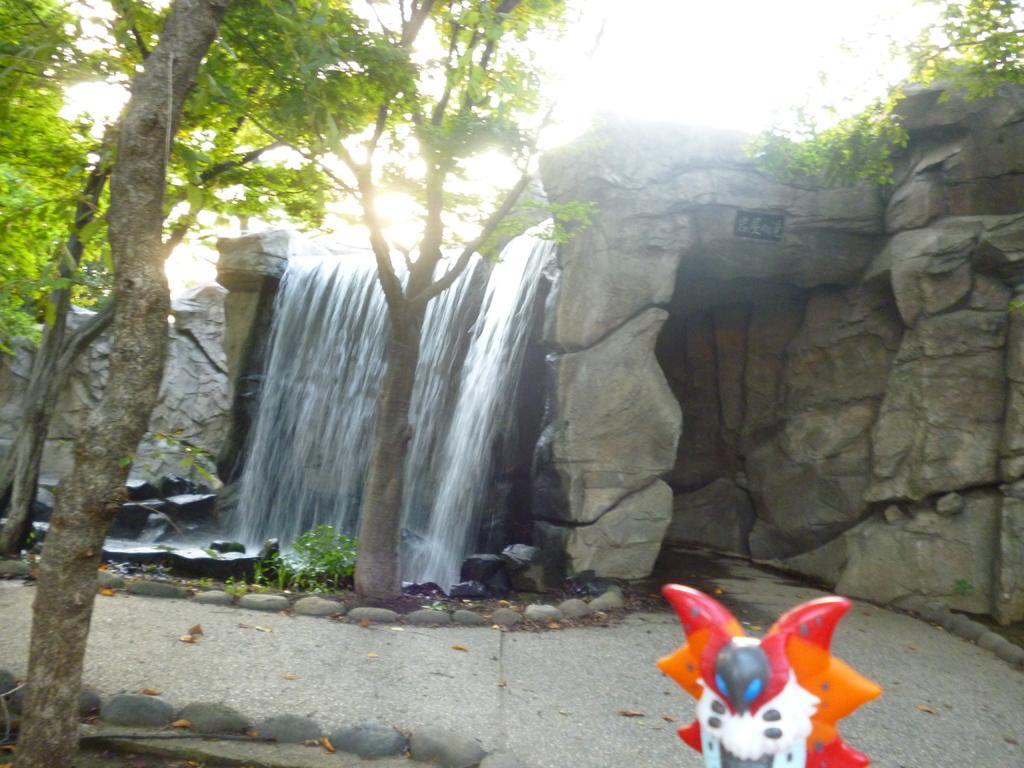Can you describe this image briefly? In the foreground of this image, on the bottom, there is a toy like an object. On the left, there is a tree and pebble stones are surrounding it. In the background, there is a water falls, trees, a plant, rock, stones, the sunny sky and the cave. 